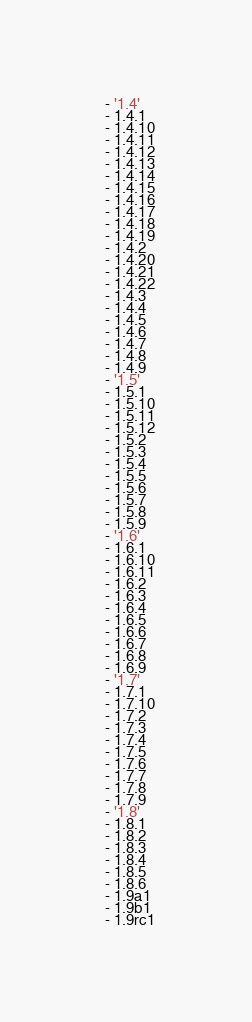Convert code to text. <code><loc_0><loc_0><loc_500><loc_500><_YAML_>  - '1.4'
  - 1.4.1
  - 1.4.10
  - 1.4.11
  - 1.4.12
  - 1.4.13
  - 1.4.14
  - 1.4.15
  - 1.4.16
  - 1.4.17
  - 1.4.18
  - 1.4.19
  - 1.4.2
  - 1.4.20
  - 1.4.21
  - 1.4.22
  - 1.4.3
  - 1.4.4
  - 1.4.5
  - 1.4.6
  - 1.4.7
  - 1.4.8
  - 1.4.9
  - '1.5'
  - 1.5.1
  - 1.5.10
  - 1.5.11
  - 1.5.12
  - 1.5.2
  - 1.5.3
  - 1.5.4
  - 1.5.5
  - 1.5.6
  - 1.5.7
  - 1.5.8
  - 1.5.9
  - '1.6'
  - 1.6.1
  - 1.6.10
  - 1.6.11
  - 1.6.2
  - 1.6.3
  - 1.6.4
  - 1.6.5
  - 1.6.6
  - 1.6.7
  - 1.6.8
  - 1.6.9
  - '1.7'
  - 1.7.1
  - 1.7.10
  - 1.7.2
  - 1.7.3
  - 1.7.4
  - 1.7.5
  - 1.7.6
  - 1.7.7
  - 1.7.8
  - 1.7.9
  - '1.8'
  - 1.8.1
  - 1.8.2
  - 1.8.3
  - 1.8.4
  - 1.8.5
  - 1.8.6
  - 1.9a1
  - 1.9b1
  - 1.9rc1
</code> 